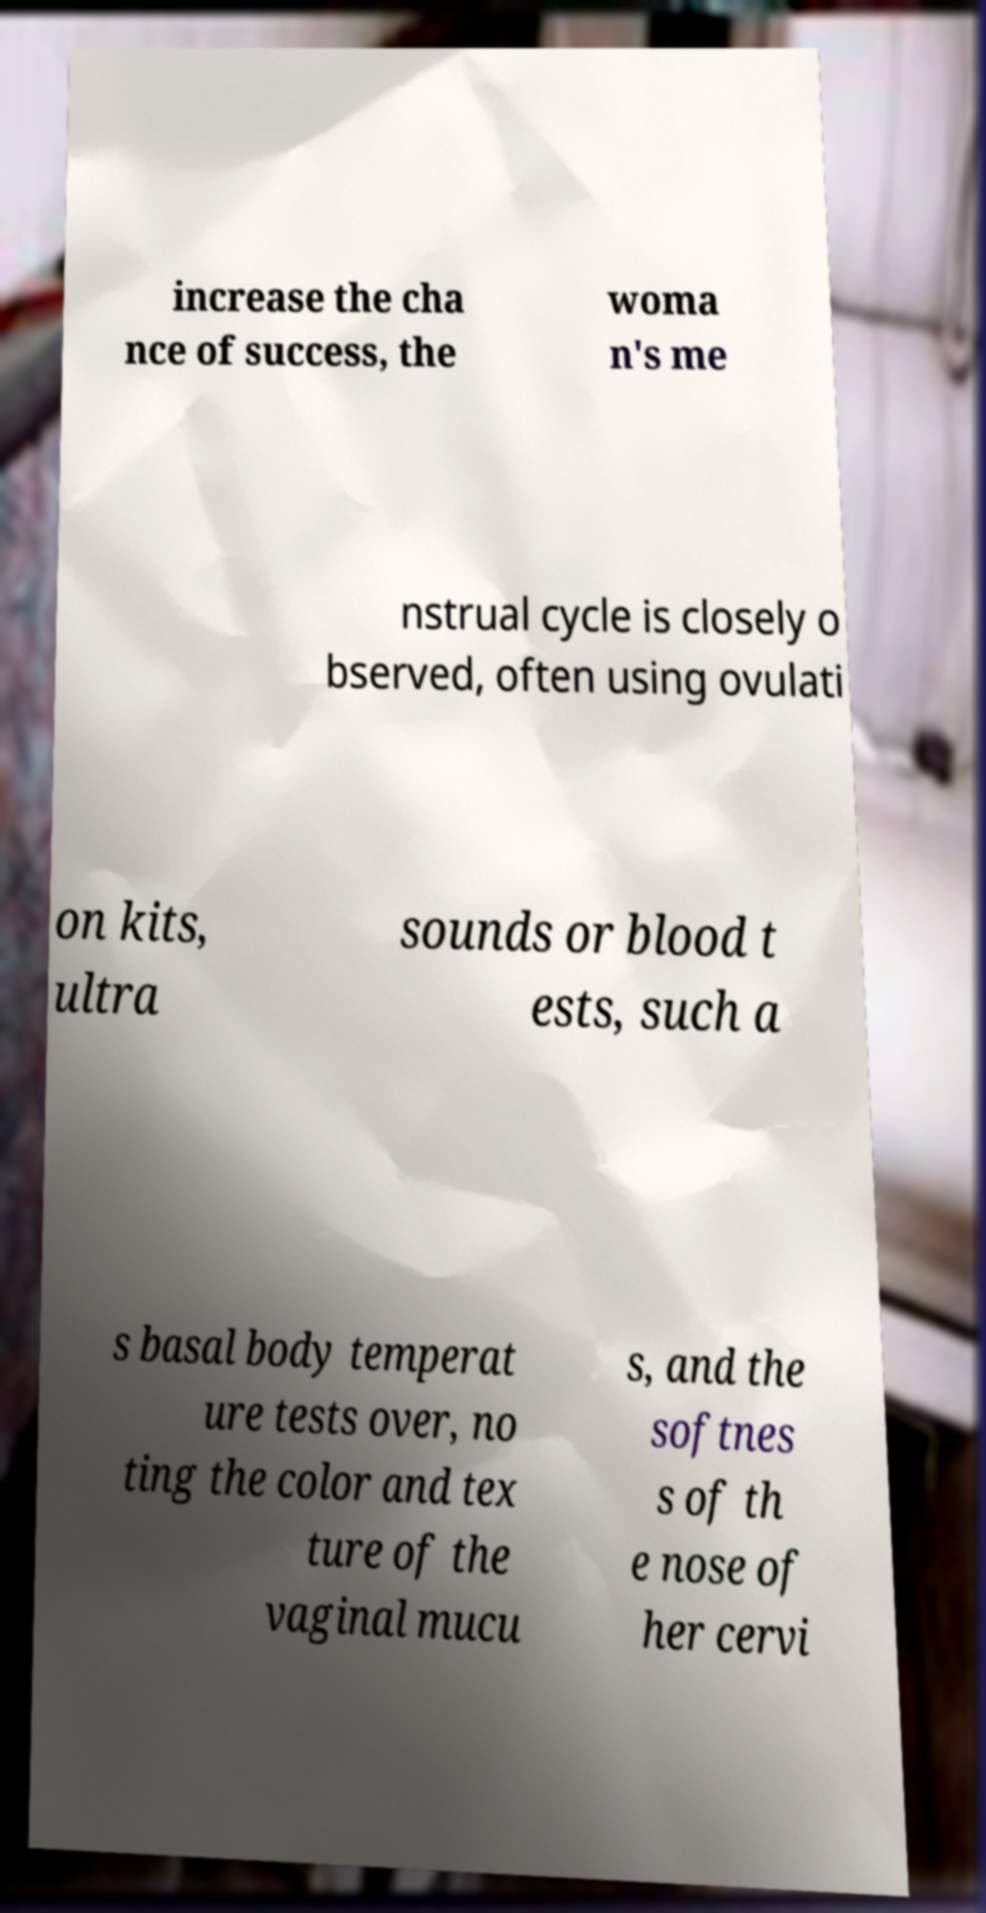Could you assist in decoding the text presented in this image and type it out clearly? increase the cha nce of success, the woma n's me nstrual cycle is closely o bserved, often using ovulati on kits, ultra sounds or blood t ests, such a s basal body temperat ure tests over, no ting the color and tex ture of the vaginal mucu s, and the softnes s of th e nose of her cervi 